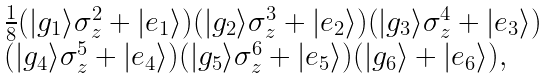Convert formula to latex. <formula><loc_0><loc_0><loc_500><loc_500>\begin{array} { l } \frac { 1 } { 8 } ( | g _ { 1 } \rangle \sigma _ { z } ^ { 2 } + | e _ { 1 } \rangle ) ( | g _ { 2 } \rangle \sigma _ { z } ^ { 3 } + | e _ { 2 } \rangle ) ( | g _ { 3 } \rangle \sigma _ { z } ^ { 4 } + | e _ { 3 } \rangle ) \\ ( | g _ { 4 } \rangle \sigma _ { z } ^ { 5 } + | e _ { 4 } \rangle ) ( | g _ { 5 } \rangle \sigma _ { z } ^ { 6 } + | e _ { 5 } \rangle ) ( | g _ { 6 } \rangle + | e _ { 6 } \rangle ) , \end{array}</formula> 